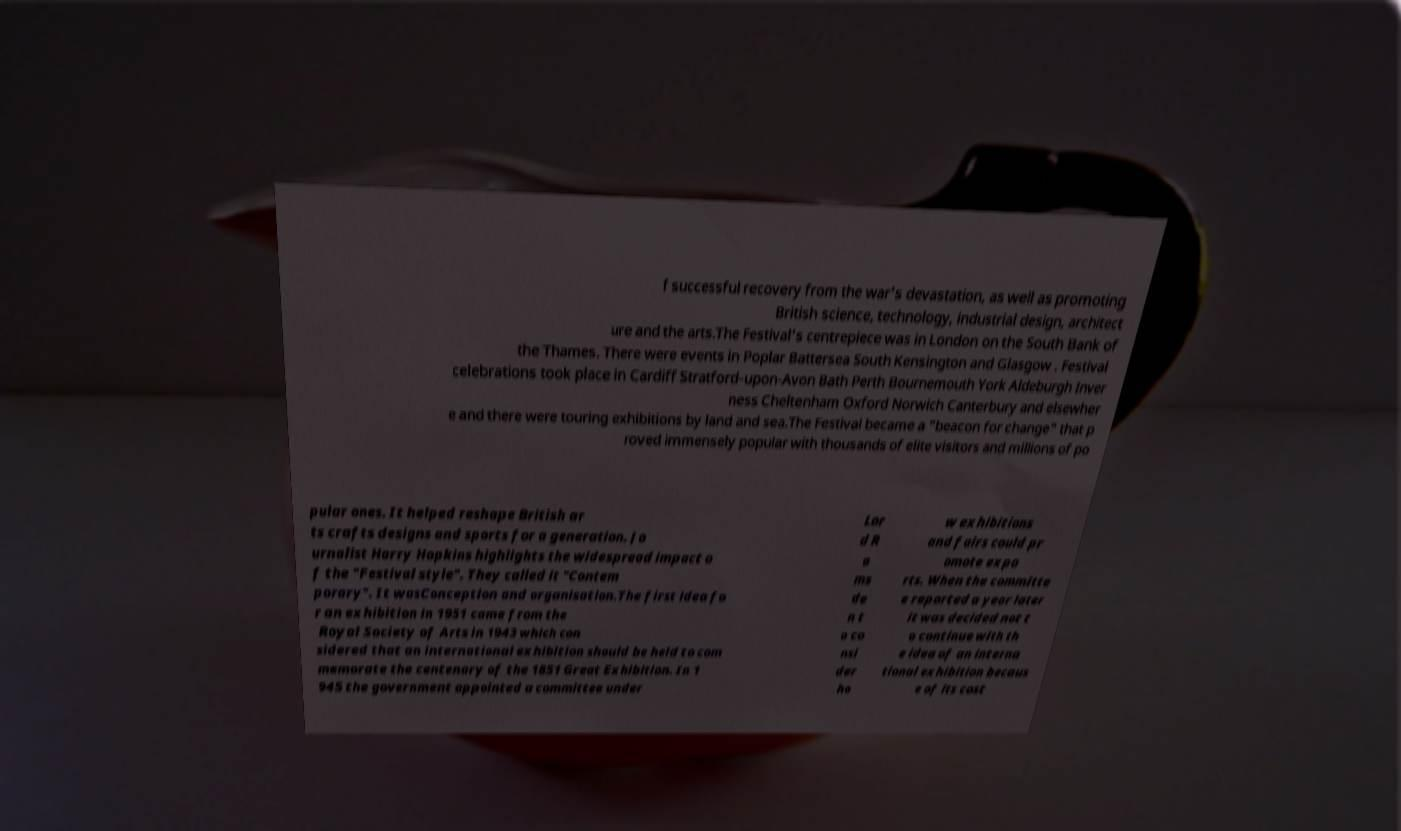Please read and relay the text visible in this image. What does it say? f successful recovery from the war's devastation, as well as promoting British science, technology, industrial design, architect ure and the arts.The Festival's centrepiece was in London on the South Bank of the Thames. There were events in Poplar Battersea South Kensington and Glasgow . Festival celebrations took place in Cardiff Stratford-upon-Avon Bath Perth Bournemouth York Aldeburgh Inver ness Cheltenham Oxford Norwich Canterbury and elsewher e and there were touring exhibitions by land and sea.The Festival became a "beacon for change" that p roved immensely popular with thousands of elite visitors and millions of po pular ones. It helped reshape British ar ts crafts designs and sports for a generation. Jo urnalist Harry Hopkins highlights the widespread impact o f the "Festival style". They called it "Contem porary". It wasConception and organisation.The first idea fo r an exhibition in 1951 came from the Royal Society of Arts in 1943 which con sidered that an international exhibition should be held to com memorate the centenary of the 1851 Great Exhibition. In 1 945 the government appointed a committee under Lor d R a ms de n t o co nsi der ho w exhibitions and fairs could pr omote expo rts. When the committe e reported a year later it was decided not t o continue with th e idea of an interna tional exhibition becaus e of its cost 